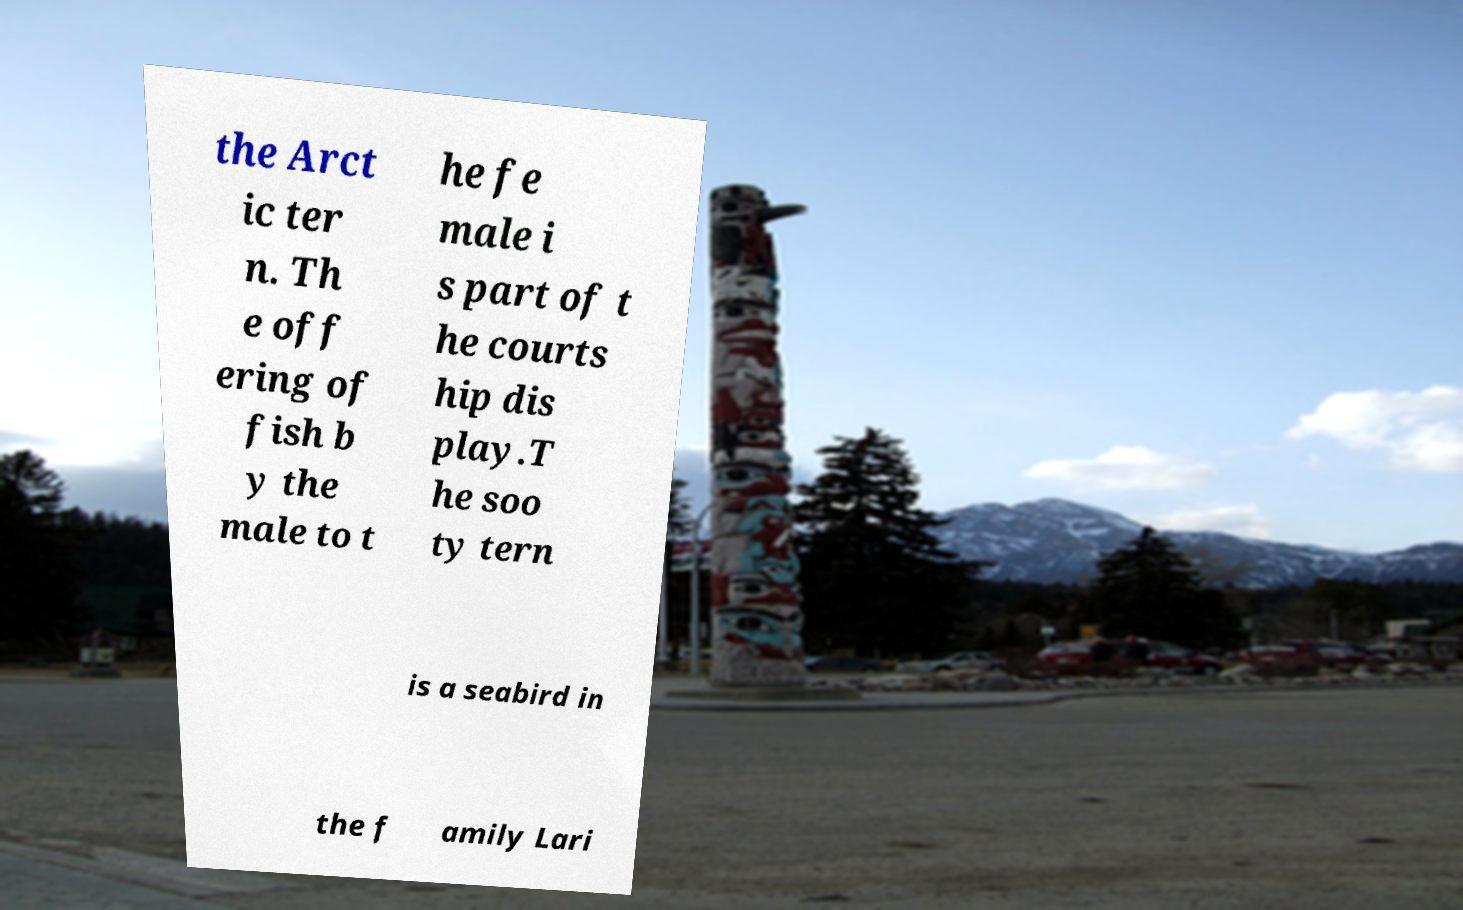I need the written content from this picture converted into text. Can you do that? the Arct ic ter n. Th e off ering of fish b y the male to t he fe male i s part of t he courts hip dis play.T he soo ty tern is a seabird in the f amily Lari 